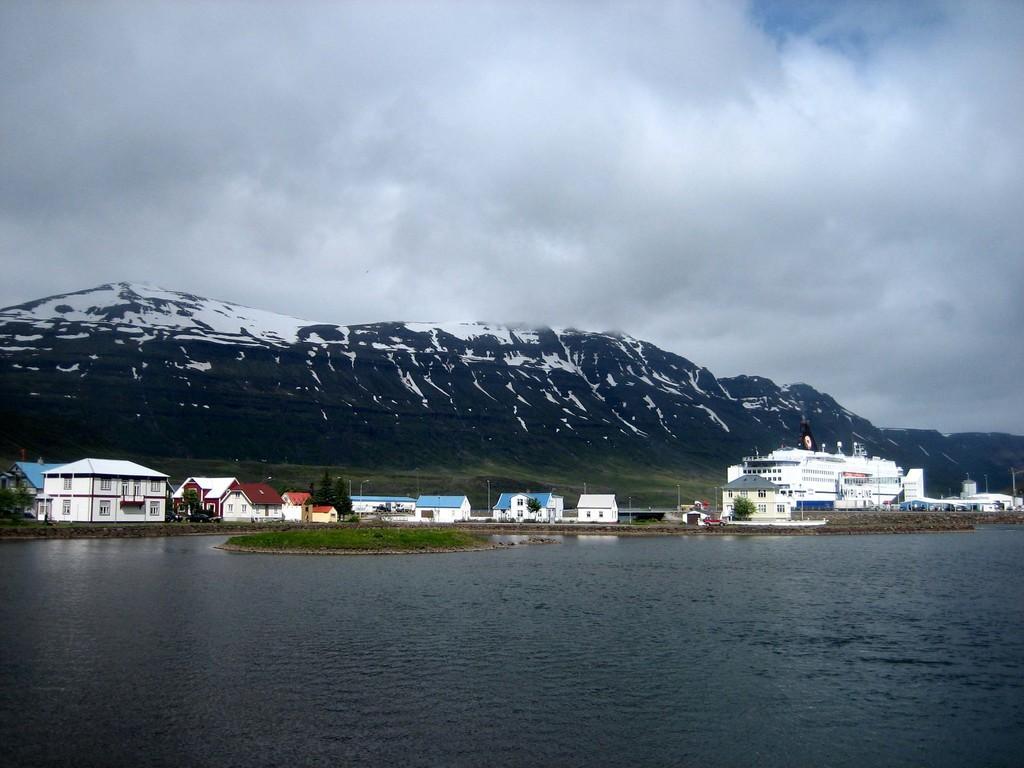How would you summarize this image in a sentence or two? In this picture i can see water, houses and trees. On the right side i can see white color ship. In the background i can see mountains and sky. 